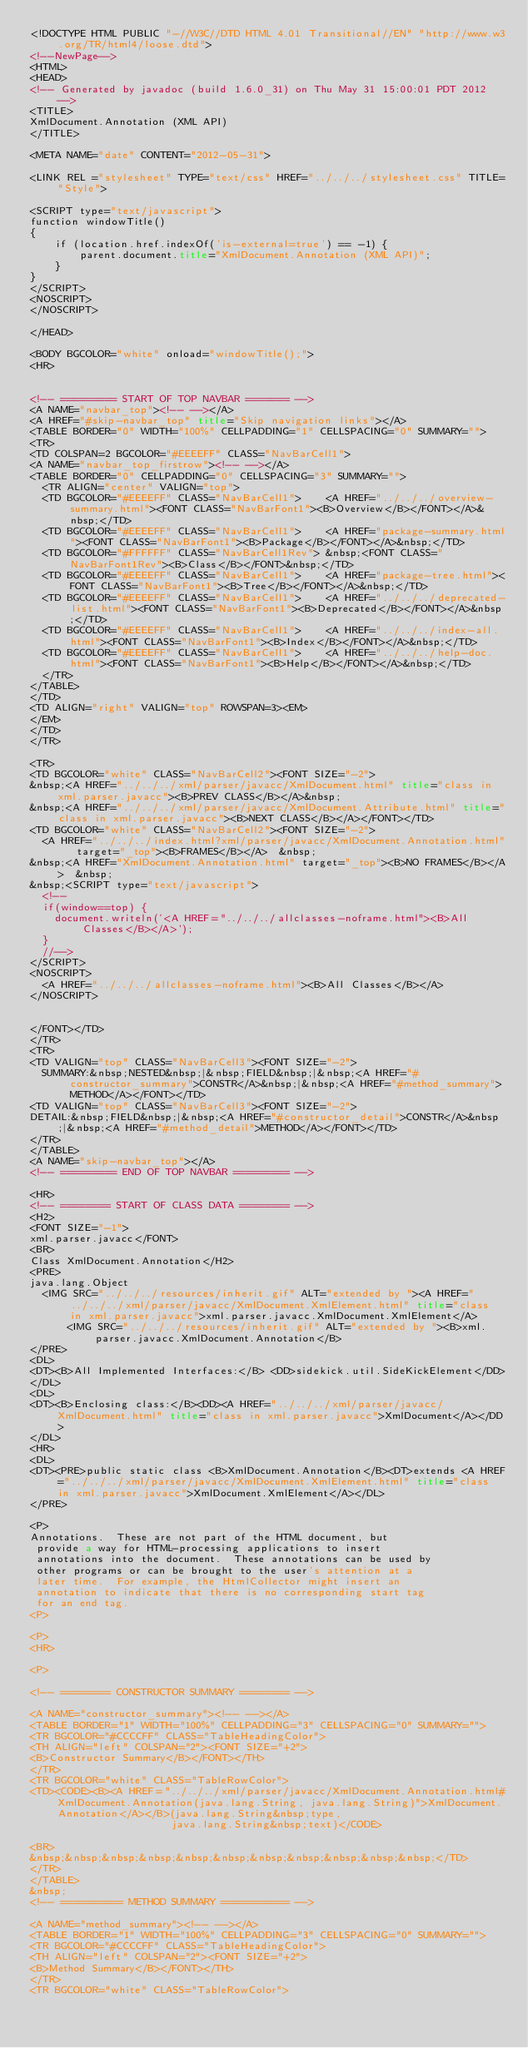Convert code to text. <code><loc_0><loc_0><loc_500><loc_500><_HTML_><!DOCTYPE HTML PUBLIC "-//W3C//DTD HTML 4.01 Transitional//EN" "http://www.w3.org/TR/html4/loose.dtd">
<!--NewPage-->
<HTML>
<HEAD>
<!-- Generated by javadoc (build 1.6.0_31) on Thu May 31 15:00:01 PDT 2012 -->
<TITLE>
XmlDocument.Annotation (XML API)
</TITLE>

<META NAME="date" CONTENT="2012-05-31">

<LINK REL ="stylesheet" TYPE="text/css" HREF="../../../stylesheet.css" TITLE="Style">

<SCRIPT type="text/javascript">
function windowTitle()
{
    if (location.href.indexOf('is-external=true') == -1) {
        parent.document.title="XmlDocument.Annotation (XML API)";
    }
}
</SCRIPT>
<NOSCRIPT>
</NOSCRIPT>

</HEAD>

<BODY BGCOLOR="white" onload="windowTitle();">
<HR>


<!-- ========= START OF TOP NAVBAR ======= -->
<A NAME="navbar_top"><!-- --></A>
<A HREF="#skip-navbar_top" title="Skip navigation links"></A>
<TABLE BORDER="0" WIDTH="100%" CELLPADDING="1" CELLSPACING="0" SUMMARY="">
<TR>
<TD COLSPAN=2 BGCOLOR="#EEEEFF" CLASS="NavBarCell1">
<A NAME="navbar_top_firstrow"><!-- --></A>
<TABLE BORDER="0" CELLPADDING="0" CELLSPACING="3" SUMMARY="">
  <TR ALIGN="center" VALIGN="top">
  <TD BGCOLOR="#EEEEFF" CLASS="NavBarCell1">    <A HREF="../../../overview-summary.html"><FONT CLASS="NavBarFont1"><B>Overview</B></FONT></A>&nbsp;</TD>
  <TD BGCOLOR="#EEEEFF" CLASS="NavBarCell1">    <A HREF="package-summary.html"><FONT CLASS="NavBarFont1"><B>Package</B></FONT></A>&nbsp;</TD>
  <TD BGCOLOR="#FFFFFF" CLASS="NavBarCell1Rev"> &nbsp;<FONT CLASS="NavBarFont1Rev"><B>Class</B></FONT>&nbsp;</TD>
  <TD BGCOLOR="#EEEEFF" CLASS="NavBarCell1">    <A HREF="package-tree.html"><FONT CLASS="NavBarFont1"><B>Tree</B></FONT></A>&nbsp;</TD>
  <TD BGCOLOR="#EEEEFF" CLASS="NavBarCell1">    <A HREF="../../../deprecated-list.html"><FONT CLASS="NavBarFont1"><B>Deprecated</B></FONT></A>&nbsp;</TD>
  <TD BGCOLOR="#EEEEFF" CLASS="NavBarCell1">    <A HREF="../../../index-all.html"><FONT CLASS="NavBarFont1"><B>Index</B></FONT></A>&nbsp;</TD>
  <TD BGCOLOR="#EEEEFF" CLASS="NavBarCell1">    <A HREF="../../../help-doc.html"><FONT CLASS="NavBarFont1"><B>Help</B></FONT></A>&nbsp;</TD>
  </TR>
</TABLE>
</TD>
<TD ALIGN="right" VALIGN="top" ROWSPAN=3><EM>
</EM>
</TD>
</TR>

<TR>
<TD BGCOLOR="white" CLASS="NavBarCell2"><FONT SIZE="-2">
&nbsp;<A HREF="../../../xml/parser/javacc/XmlDocument.html" title="class in xml.parser.javacc"><B>PREV CLASS</B></A>&nbsp;
&nbsp;<A HREF="../../../xml/parser/javacc/XmlDocument.Attribute.html" title="class in xml.parser.javacc"><B>NEXT CLASS</B></A></FONT></TD>
<TD BGCOLOR="white" CLASS="NavBarCell2"><FONT SIZE="-2">
  <A HREF="../../../index.html?xml/parser/javacc/XmlDocument.Annotation.html" target="_top"><B>FRAMES</B></A>  &nbsp;
&nbsp;<A HREF="XmlDocument.Annotation.html" target="_top"><B>NO FRAMES</B></A>  &nbsp;
&nbsp;<SCRIPT type="text/javascript">
  <!--
  if(window==top) {
    document.writeln('<A HREF="../../../allclasses-noframe.html"><B>All Classes</B></A>');
  }
  //-->
</SCRIPT>
<NOSCRIPT>
  <A HREF="../../../allclasses-noframe.html"><B>All Classes</B></A>
</NOSCRIPT>


</FONT></TD>
</TR>
<TR>
<TD VALIGN="top" CLASS="NavBarCell3"><FONT SIZE="-2">
  SUMMARY:&nbsp;NESTED&nbsp;|&nbsp;FIELD&nbsp;|&nbsp;<A HREF="#constructor_summary">CONSTR</A>&nbsp;|&nbsp;<A HREF="#method_summary">METHOD</A></FONT></TD>
<TD VALIGN="top" CLASS="NavBarCell3"><FONT SIZE="-2">
DETAIL:&nbsp;FIELD&nbsp;|&nbsp;<A HREF="#constructor_detail">CONSTR</A>&nbsp;|&nbsp;<A HREF="#method_detail">METHOD</A></FONT></TD>
</TR>
</TABLE>
<A NAME="skip-navbar_top"></A>
<!-- ========= END OF TOP NAVBAR ========= -->

<HR>
<!-- ======== START OF CLASS DATA ======== -->
<H2>
<FONT SIZE="-1">
xml.parser.javacc</FONT>
<BR>
Class XmlDocument.Annotation</H2>
<PRE>
java.lang.Object
  <IMG SRC="../../../resources/inherit.gif" ALT="extended by "><A HREF="../../../xml/parser/javacc/XmlDocument.XmlElement.html" title="class in xml.parser.javacc">xml.parser.javacc.XmlDocument.XmlElement</A>
      <IMG SRC="../../../resources/inherit.gif" ALT="extended by "><B>xml.parser.javacc.XmlDocument.Annotation</B>
</PRE>
<DL>
<DT><B>All Implemented Interfaces:</B> <DD>sidekick.util.SideKickElement</DD>
</DL>
<DL>
<DT><B>Enclosing class:</B><DD><A HREF="../../../xml/parser/javacc/XmlDocument.html" title="class in xml.parser.javacc">XmlDocument</A></DD>
</DL>
<HR>
<DL>
<DT><PRE>public static class <B>XmlDocument.Annotation</B><DT>extends <A HREF="../../../xml/parser/javacc/XmlDocument.XmlElement.html" title="class in xml.parser.javacc">XmlDocument.XmlElement</A></DL>
</PRE>

<P>
Annotations.  These are not part of the HTML document, but
 provide a way for HTML-processing applications to insert
 annotations into the document.  These annotations can be used by
 other programs or can be brought to the user's attention at a
 later time.  For example, the HtmlCollector might insert an
 annotation to indicate that there is no corresponding start tag
 for an end tag.
<P>

<P>
<HR>

<P>

<!-- ======== CONSTRUCTOR SUMMARY ======== -->

<A NAME="constructor_summary"><!-- --></A>
<TABLE BORDER="1" WIDTH="100%" CELLPADDING="3" CELLSPACING="0" SUMMARY="">
<TR BGCOLOR="#CCCCFF" CLASS="TableHeadingColor">
<TH ALIGN="left" COLSPAN="2"><FONT SIZE="+2">
<B>Constructor Summary</B></FONT></TH>
</TR>
<TR BGCOLOR="white" CLASS="TableRowColor">
<TD><CODE><B><A HREF="../../../xml/parser/javacc/XmlDocument.Annotation.html#XmlDocument.Annotation(java.lang.String, java.lang.String)">XmlDocument.Annotation</A></B>(java.lang.String&nbsp;type,
                       java.lang.String&nbsp;text)</CODE>

<BR>
&nbsp;&nbsp;&nbsp;&nbsp;&nbsp;&nbsp;&nbsp;&nbsp;&nbsp;&nbsp;&nbsp;</TD>
</TR>
</TABLE>
&nbsp;
<!-- ========== METHOD SUMMARY =========== -->

<A NAME="method_summary"><!-- --></A>
<TABLE BORDER="1" WIDTH="100%" CELLPADDING="3" CELLSPACING="0" SUMMARY="">
<TR BGCOLOR="#CCCCFF" CLASS="TableHeadingColor">
<TH ALIGN="left" COLSPAN="2"><FONT SIZE="+2">
<B>Method Summary</B></FONT></TH>
</TR>
<TR BGCOLOR="white" CLASS="TableRowColor"></code> 